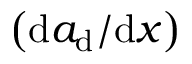<formula> <loc_0><loc_0><loc_500><loc_500>\left ( { d a _ { d } } / { d x } \right )</formula> 